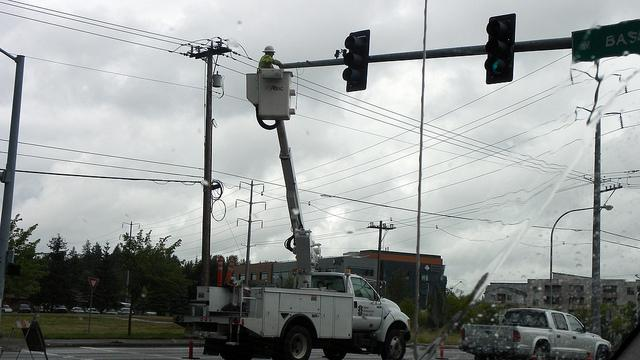What sort of repairs in the lifted person doing? Please explain your reasoning. electrical. The traffic lights run on electricity. 